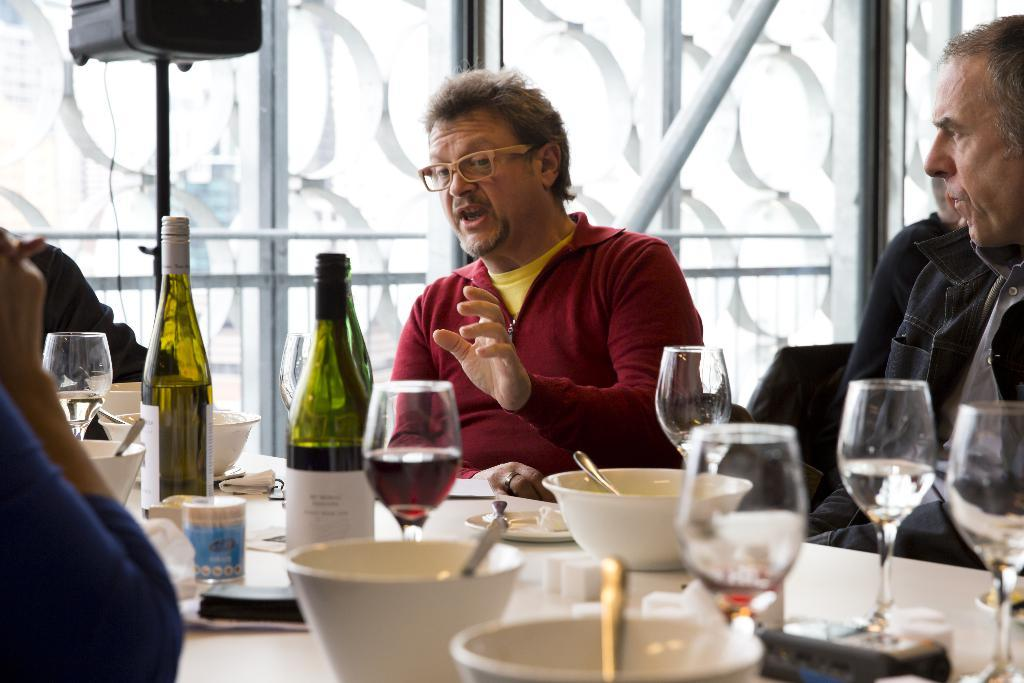What are the people in the image doing? The people in the image are sitting in chairs. Where are the chairs located in relation to the table? The chairs are in front of a table. What can be seen on the table in the image? There are wine bottles, glasses, and other objects on the table. What type of toothbrush is being used by the son in the image? There is no toothbrush or son present in the image. How is the transport being utilized in the image? There is no transport present in the image. 